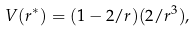Convert formula to latex. <formula><loc_0><loc_0><loc_500><loc_500>V ( r ^ { * } ) = ( 1 - 2 / r ) ( 2 / r ^ { 3 } ) ,</formula> 